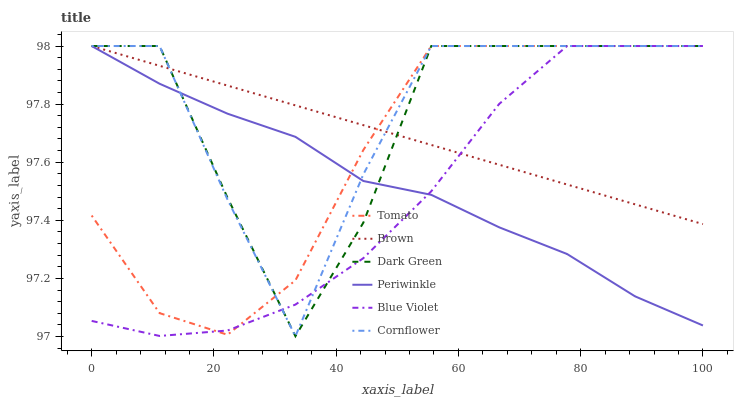Does Blue Violet have the minimum area under the curve?
Answer yes or no. Yes. Does Cornflower have the maximum area under the curve?
Answer yes or no. Yes. Does Brown have the minimum area under the curve?
Answer yes or no. No. Does Brown have the maximum area under the curve?
Answer yes or no. No. Is Brown the smoothest?
Answer yes or no. Yes. Is Dark Green the roughest?
Answer yes or no. Yes. Is Cornflower the smoothest?
Answer yes or no. No. Is Cornflower the roughest?
Answer yes or no. No. Does Cornflower have the lowest value?
Answer yes or no. Yes. Does Brown have the lowest value?
Answer yes or no. No. Does Dark Green have the highest value?
Answer yes or no. Yes. Does Dark Green intersect Blue Violet?
Answer yes or no. Yes. Is Dark Green less than Blue Violet?
Answer yes or no. No. Is Dark Green greater than Blue Violet?
Answer yes or no. No. 